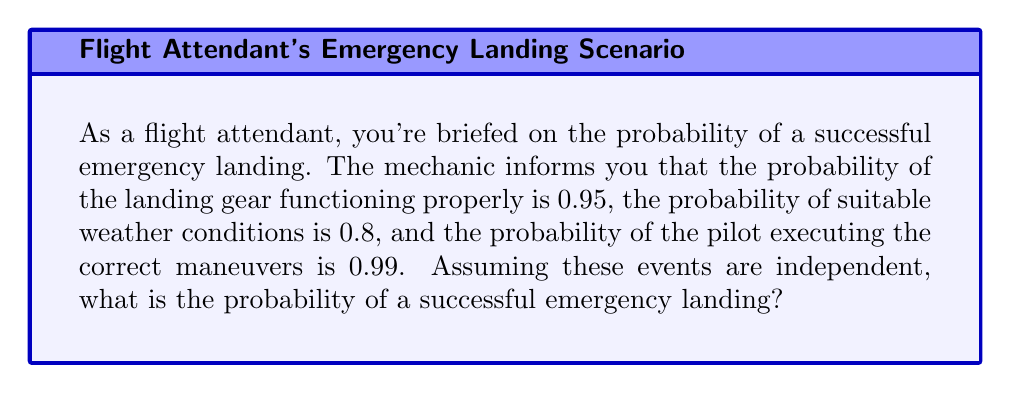Could you help me with this problem? To solve this problem, we need to follow these steps:

1) We are given three independent probabilities:
   - Probability of landing gear functioning: $P(G) = 0.95$
   - Probability of suitable weather: $P(W) = 0.8$
   - Probability of correct pilot maneuvers: $P(P) = 0.99$

2) For a successful emergency landing, all three events need to occur simultaneously. Since the events are independent, we can use the multiplication rule of probability.

3) The probability of all independent events occurring together is the product of their individual probabilities:

   $$P(\text{Successful Landing}) = P(G) \times P(W) \times P(P)$$

4) Substituting the given probabilities:

   $$P(\text{Successful Landing}) = 0.95 \times 0.8 \times 0.99$$

5) Calculating:
   
   $$P(\text{Successful Landing}) = 0.7524$$

6) Converting to a percentage:

   $$0.7524 \times 100\% = 75.24\%$$

Therefore, the probability of a successful emergency landing under these conditions is approximately 75.24%.
Answer: $0.7524$ or $75.24\%$ 